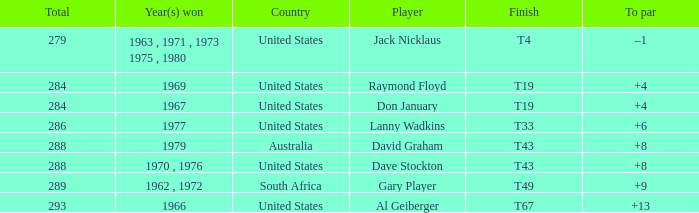Who won in 1979 with +8 to par? David Graham. 